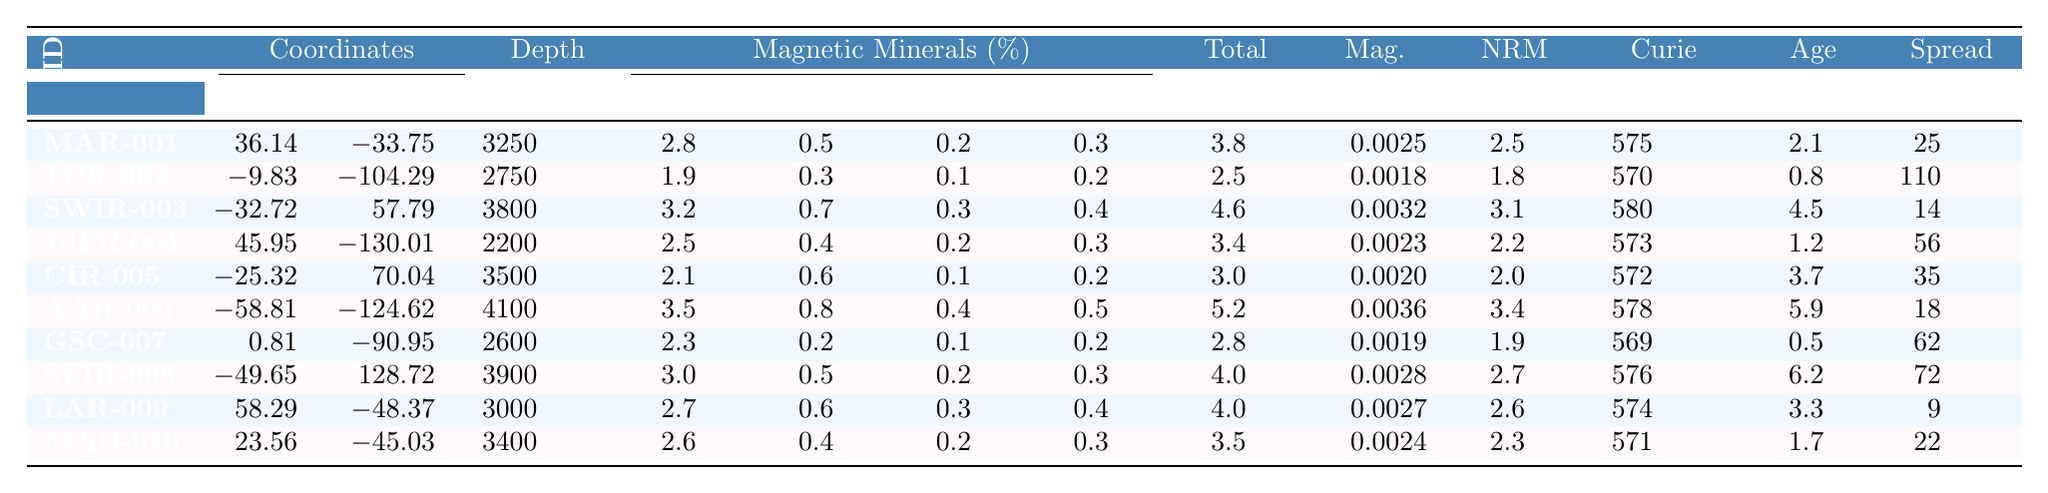What is the location of sample MAR-001? The location for sample MAR-001 is listed in the table under the "Location" column. It shows "Mid-Atlantic Ridge".
Answer: Mid-Atlantic Ridge Which sample has the highest percentage of magnetite? By scanning the "Magnetite_percent" column, the maximum value is 3.5%, found in sample AAR-006.
Answer: AAR-006 What is the age (in million years) of the sample located at South West Indian Ridge? The location "Southwest Indian Ridge" corresponds to sample SWIR-003. Referring to the "Age_Ma" column, it lists an age of 4.5 million years.
Answer: 4.5 Which sample has the lowest hematite percentage, and what is that percentage? The "Hematite_percent" column shows the lowest value of 0.2% for sample GSC-007.
Answer: GSC-007, 0.2% Calculate the average depth of all samples. The depth values are (3250 + 2750 + 3800 + 2200 + 3500 + 4100 + 2600 + 3900 + 3000 + 3400) =  32,600, and there are 10 samples. The average depth is 32,600 / 10 = 3,260 meters.
Answer: 3,260 Is the magnetic susceptibility of sample EPR-002 greater than the average of all samples? First, we check the value for EPR-002, which is 0.0018. Next, calculate the average susceptibility: (0.0025 + 0.0018 + 0.0032 + 0.0023 + 0.0020 + 0.0036 + 0.0019 + 0.0028 + 0.0027 + 0.0024) / 10 = 0.0024. Since 0.0018 is less than 0.0024, the answer is no.
Answer: No What is the total percentage of magnetic minerals in the sample from the Juan de Fuca Ridge? In the table, the total magnetic minerals percentage for sample JdFR-004 is indicated as 3.4%.
Answer: 3.4 Identify the sample with the highest spreading rate and provide that rate. Checking the "Spreading_rate_mm_yr" column, sample EPR-002 has the highest value of 110 mm/yr.
Answer: EPR-002, 110 mm/yr Which sample has a Curie temperature less than 570°C? Referring to the "Curie_temperature_C" column, the only sample with a temperature below 570°C is GSC-007, with a Curie temperature of 569°C.
Answer: GSC-007 If the magnetite percentage of sample SWIR-003 is increased by 0.5%, what would be the new percentage? The current magnetite percentage for SWIR-003 is 3.2%. Adding 0.5% gives 3.2% + 0.5% = 3.7%.
Answer: 3.7% 